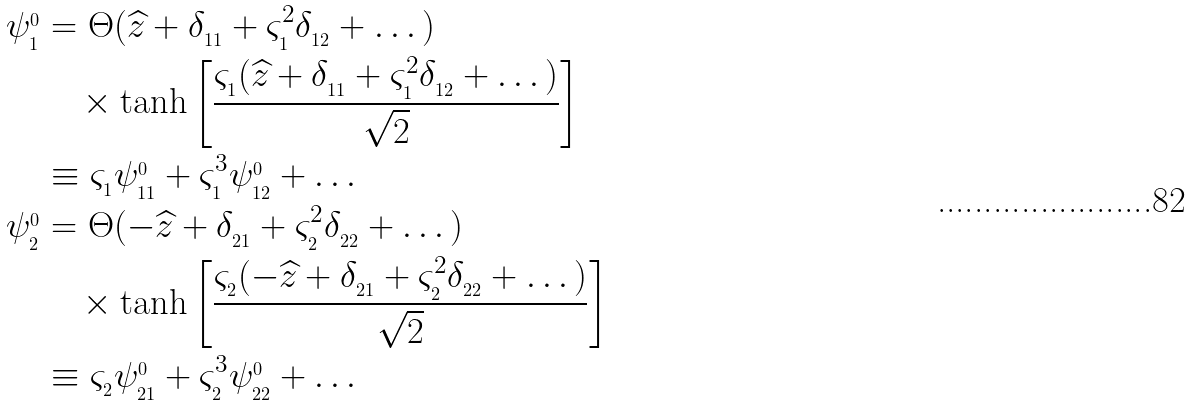<formula> <loc_0><loc_0><loc_500><loc_500>\psi _ { _ { 1 } } ^ { _ { 0 } } & = \Theta ( \widehat { z } + \delta _ { _ { 1 1 } } + \varsigma _ { _ { 1 } } ^ { 2 } \delta _ { _ { 1 2 } } + \dots ) \\ & \quad \times \tanh \left [ \frac { \varsigma _ { _ { 1 } } ( \widehat { z } + \delta _ { _ { 1 1 } } + \varsigma _ { _ { 1 } } ^ { 2 } \delta _ { _ { 1 2 } } + \dots ) } { \sqrt { 2 } } \right ] \\ & \equiv \varsigma _ { _ { 1 } } \psi _ { _ { 1 1 } } ^ { _ { 0 } } + \varsigma _ { _ { 1 } } ^ { 3 } \psi _ { _ { 1 2 } } ^ { _ { 0 } } + \dots \\ \psi _ { _ { 2 } } ^ { _ { 0 } } & = \Theta ( - \widehat { z } + \delta _ { _ { 2 1 } } + \varsigma _ { _ { 2 } } ^ { 2 } \delta _ { _ { 2 2 } } + \dots ) \\ & \quad \times \tanh \left [ \frac { \varsigma _ { _ { 2 } } ( - \widehat { z } + \delta _ { _ { 2 1 } } + \varsigma _ { _ { 2 } } ^ { 2 } \delta _ { _ { 2 2 } } + \dots ) } { \sqrt { 2 } } \right ] \\ & \equiv \varsigma _ { _ { 2 } } \psi _ { _ { 2 1 } } ^ { _ { 0 } } + \varsigma _ { _ { 2 } } ^ { 3 } \psi _ { _ { 2 2 } } ^ { _ { 0 } } + \dots</formula> 